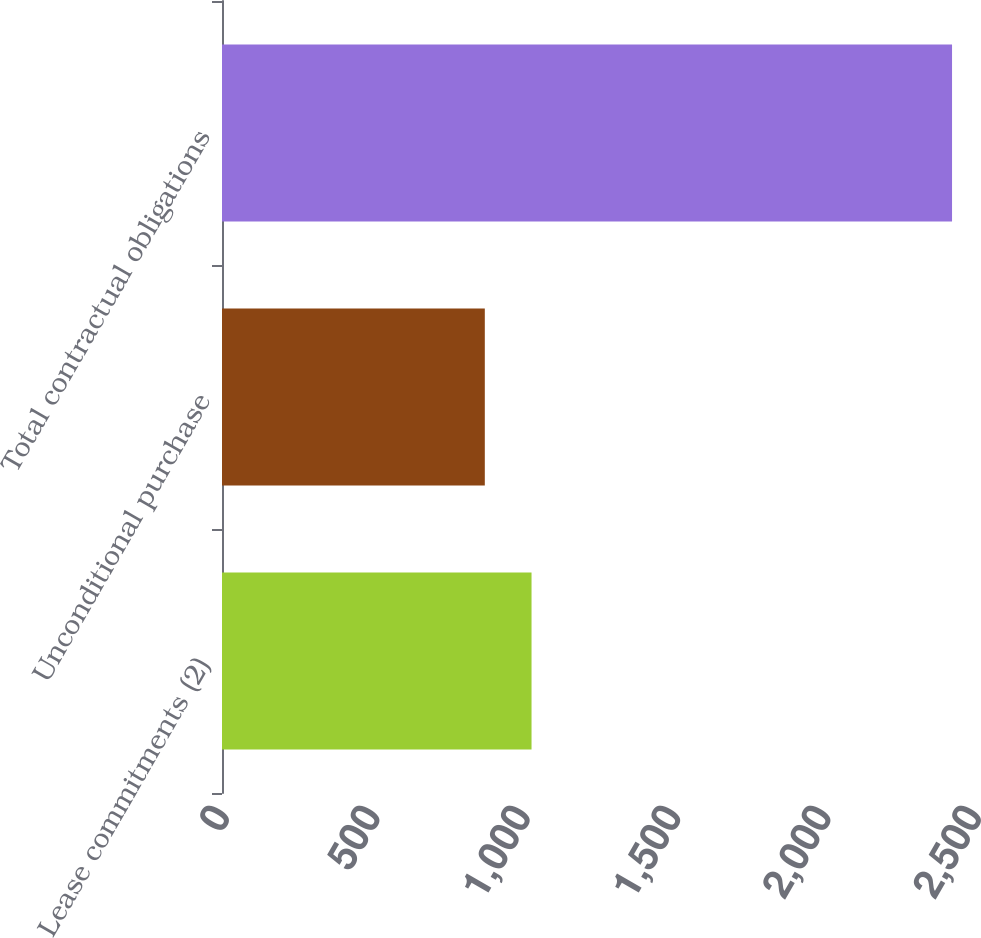Convert chart. <chart><loc_0><loc_0><loc_500><loc_500><bar_chart><fcel>Lease commitments (2)<fcel>Unconditional purchase<fcel>Total contractual obligations<nl><fcel>1029.03<fcel>873.7<fcel>2427<nl></chart> 